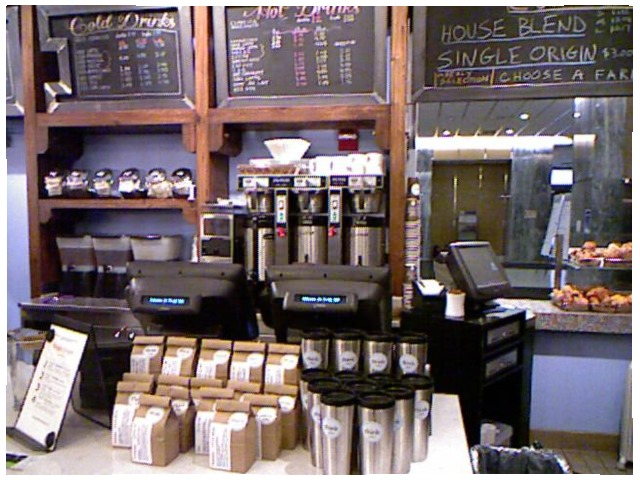<image>
Is the fluffy pastries behind the lcd monitor? Yes. From this viewpoint, the fluffy pastries is positioned behind the lcd monitor, with the lcd monitor partially or fully occluding the fluffy pastries. Is there a coffee pot behind the register? Yes. From this viewpoint, the coffee pot is positioned behind the register, with the register partially or fully occluding the coffee pot. Where is the coffee beans in relation to the pos terminal? Is it under the pos terminal? Yes. The coffee beans is positioned underneath the pos terminal, with the pos terminal above it in the vertical space. 